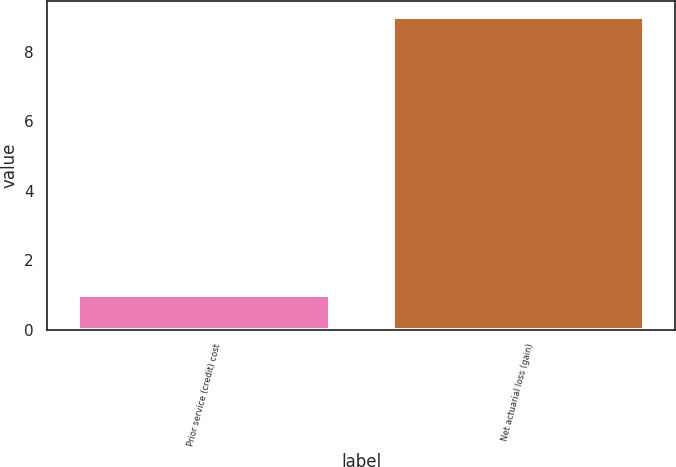Convert chart. <chart><loc_0><loc_0><loc_500><loc_500><bar_chart><fcel>Prior service (credit) cost<fcel>Net actuarial loss (gain)<nl><fcel>1<fcel>9<nl></chart> 